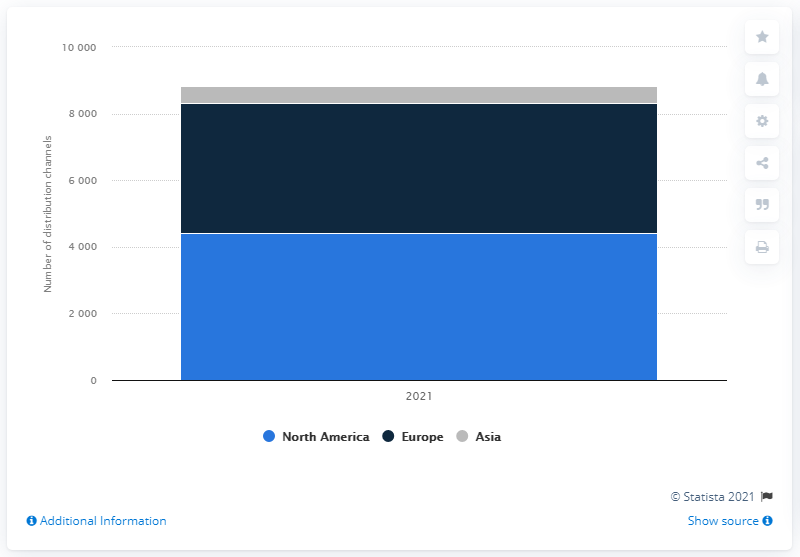Mention a couple of crucial points in this snapshot. In the year 2021, Polo Ralph Lauren operated 500 distribution channels. In 2021, Ralph Lauren operated a distribution network consisting of 500 channels in Asia, enabling the company to reach a wide and diverse customer base in the region. 